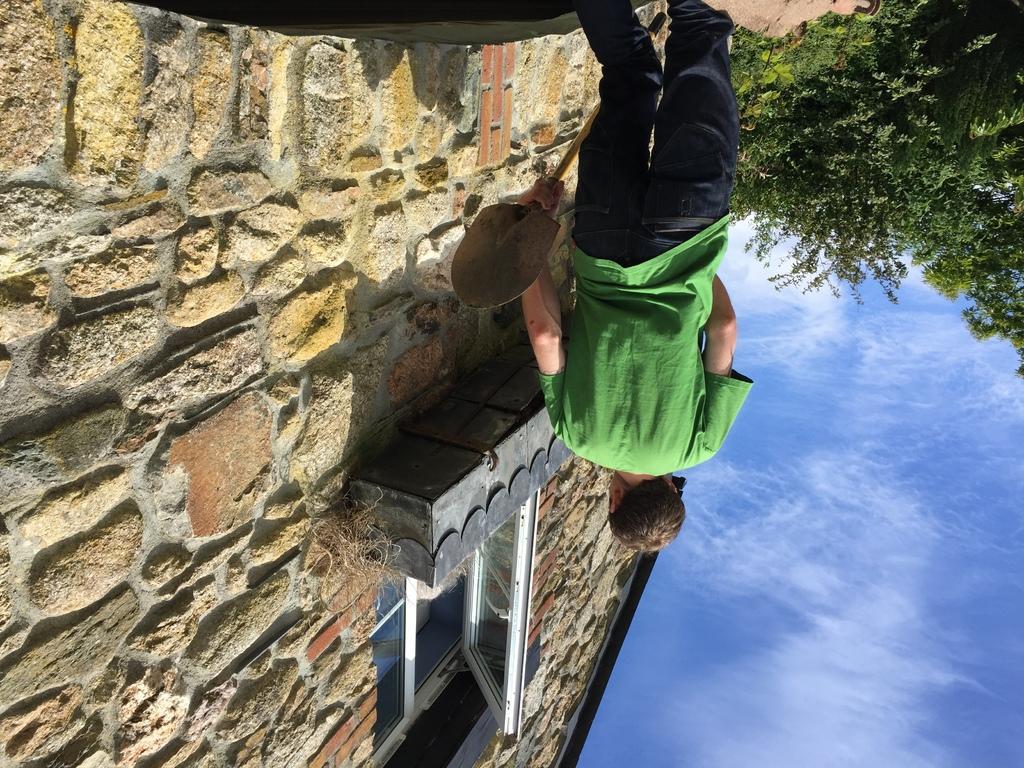Please provide a concise description of this image. In this image, we can see a person is holding a paddle Background we can see a house with wall and glass window. Right side of the image, we can see few trees, plants and sky. 